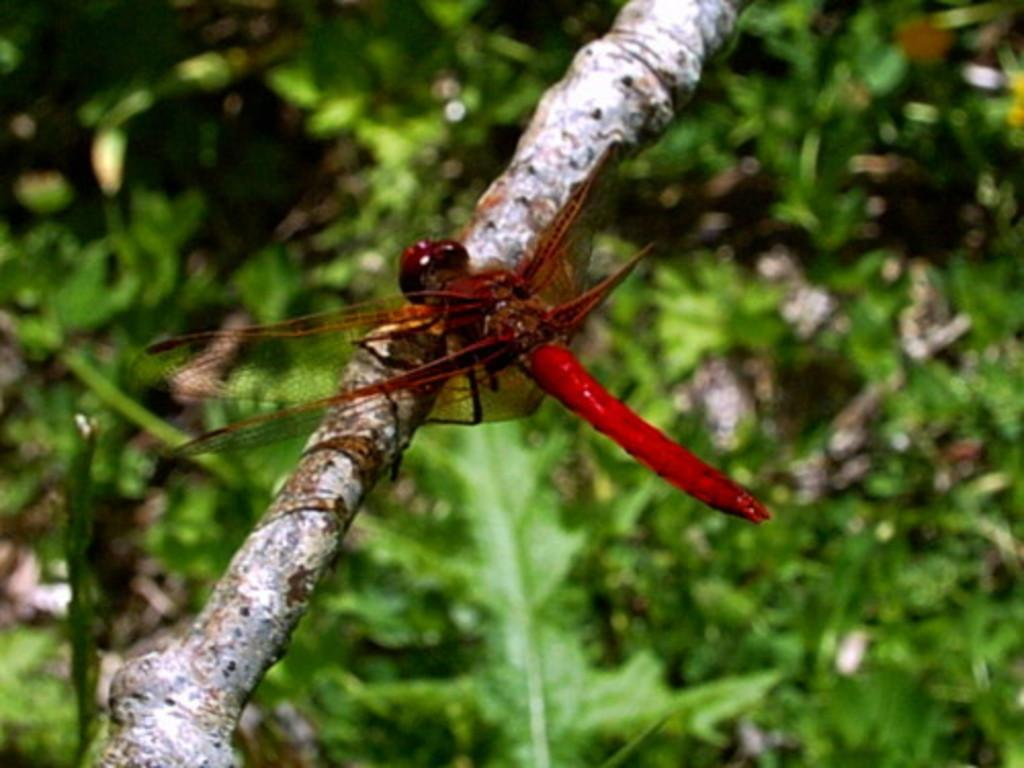What insect can be seen in the image? There is a dragonfly in the image. Where is the dragonfly located? The dragonfly is on the branch of a tree. Can you describe the background of the image? The background of the image is blurred. Is there a spy observing the dragonfly in the image? There is no indication of a spy or any human presence in the image; it only features a dragonfly on a tree branch. 